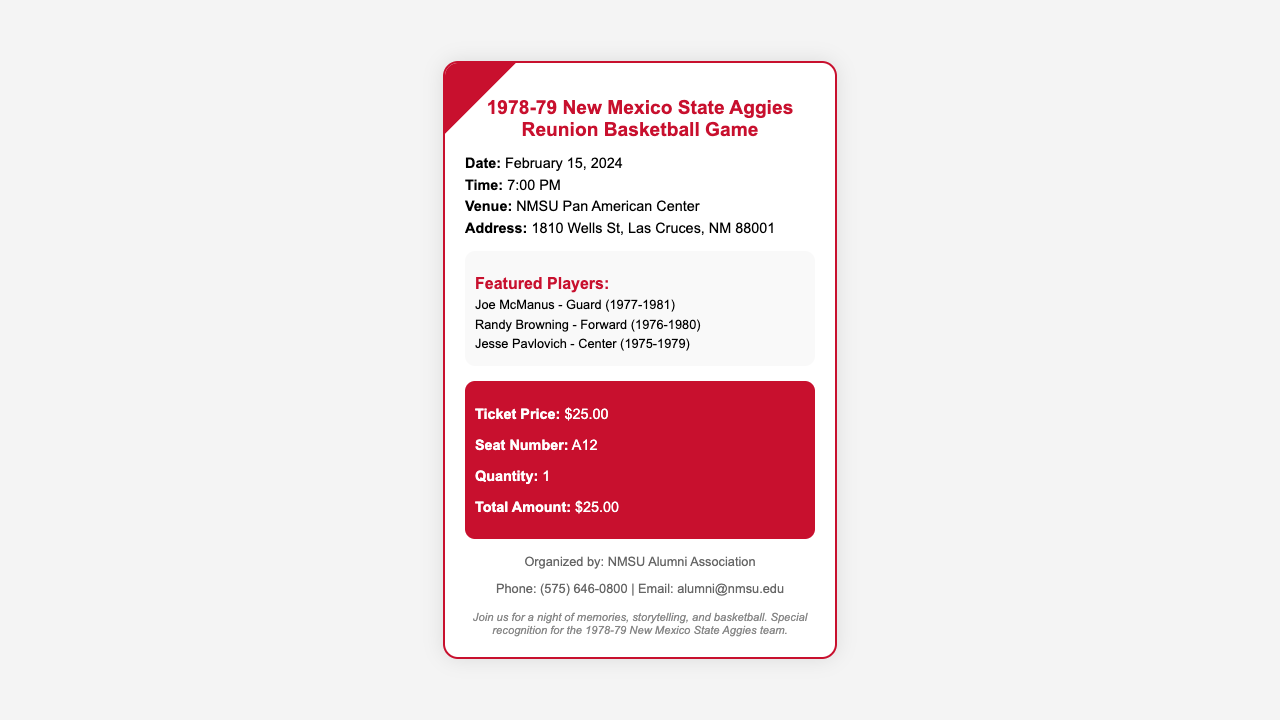What is the date of the reunion game? The date of the reunion game is provided in the document as February 15, 2024.
Answer: February 15, 2024 What time does the game start? The document specifies the start time of the game as 7:00 PM.
Answer: 7:00 PM What is the ticket price? The ticket price is detailed in the document as $25.00.
Answer: $25.00 Who is one of the featured players? The document lists several featured players; one example is Joe McManus.
Answer: Joe McManus What is the venue for the reunion game? The venue is indicated in the document as NMSU Pan American Center.
Answer: NMSU Pan American Center What is the seat number on the ticket? The ticket details specify the seat number as A12.
Answer: A12 How many tickets were purchased? The document states the quantity of tickets purchased as 1.
Answer: 1 Which organization is organizing the event? The document mentions that the event is organized by the NMSU Alumni Association.
Answer: NMSU Alumni Association What special recognition will be given during the event? The document mentions that there will be "special recognition for the 1978-79 New Mexico State Aggies team."
Answer: special recognition for the 1978-79 New Mexico State Aggies team 